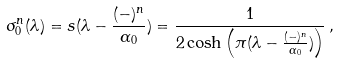<formula> <loc_0><loc_0><loc_500><loc_500>\sigma _ { 0 } ^ { n } ( \lambda ) = s ( \lambda - { \frac { ( - ) ^ { n } } { \alpha _ { 0 } } } ) = { \frac { 1 } { 2 \cosh \left ( \pi ( \lambda - { \frac { ( - ) ^ { n } } { \alpha _ { 0 } } } ) \right ) } } \, ,</formula> 